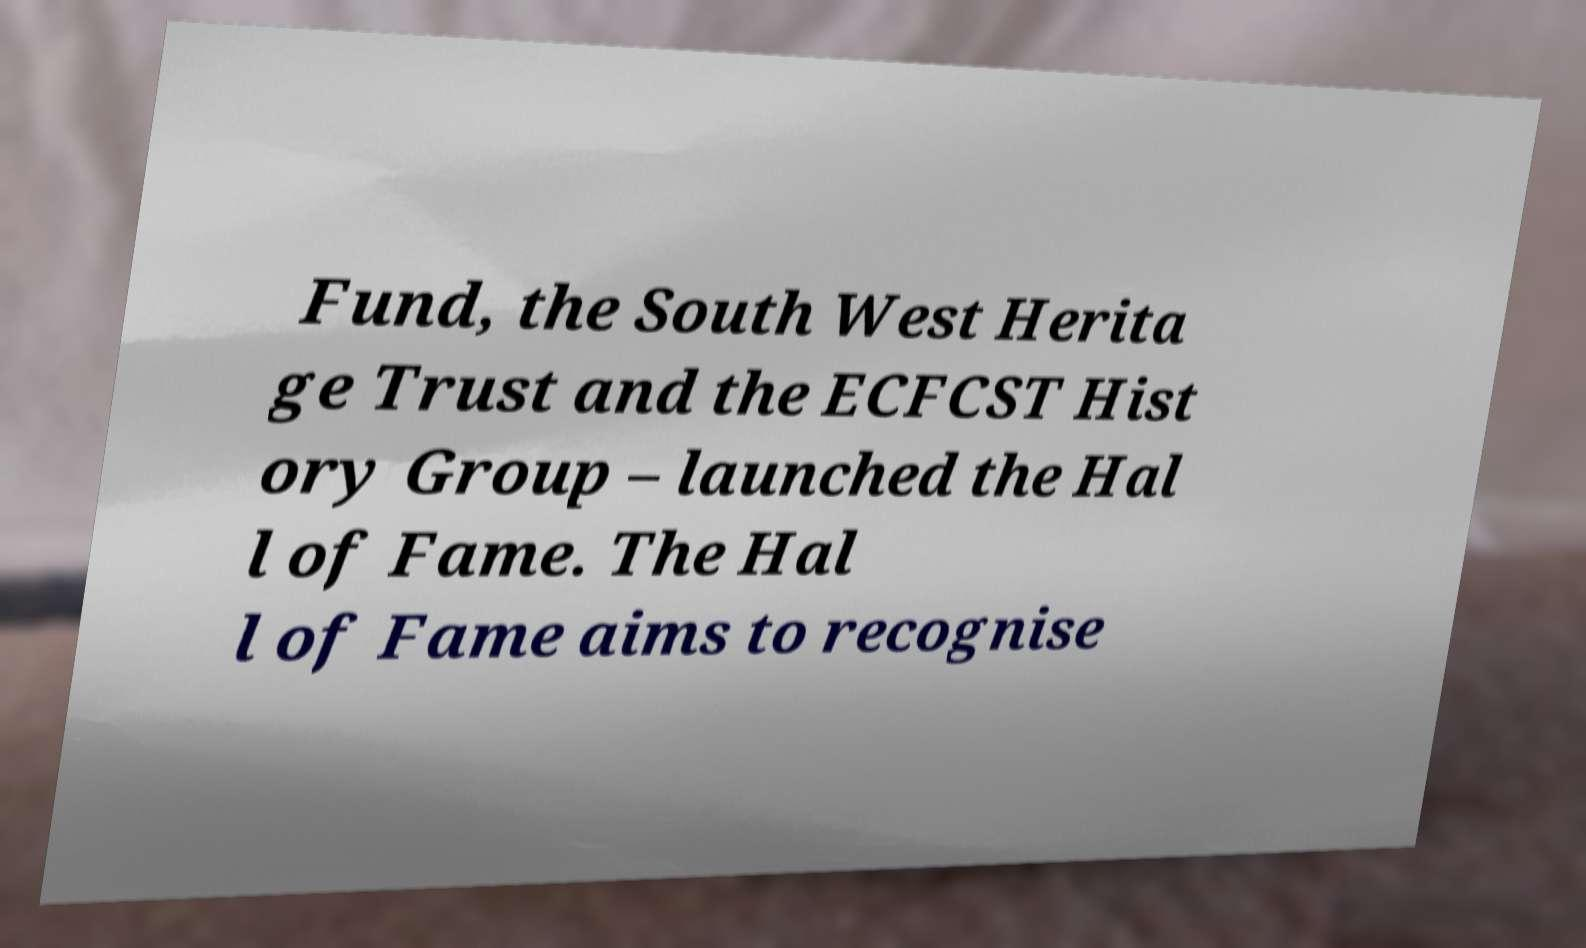There's text embedded in this image that I need extracted. Can you transcribe it verbatim? Fund, the South West Herita ge Trust and the ECFCST Hist ory Group – launched the Hal l of Fame. The Hal l of Fame aims to recognise 